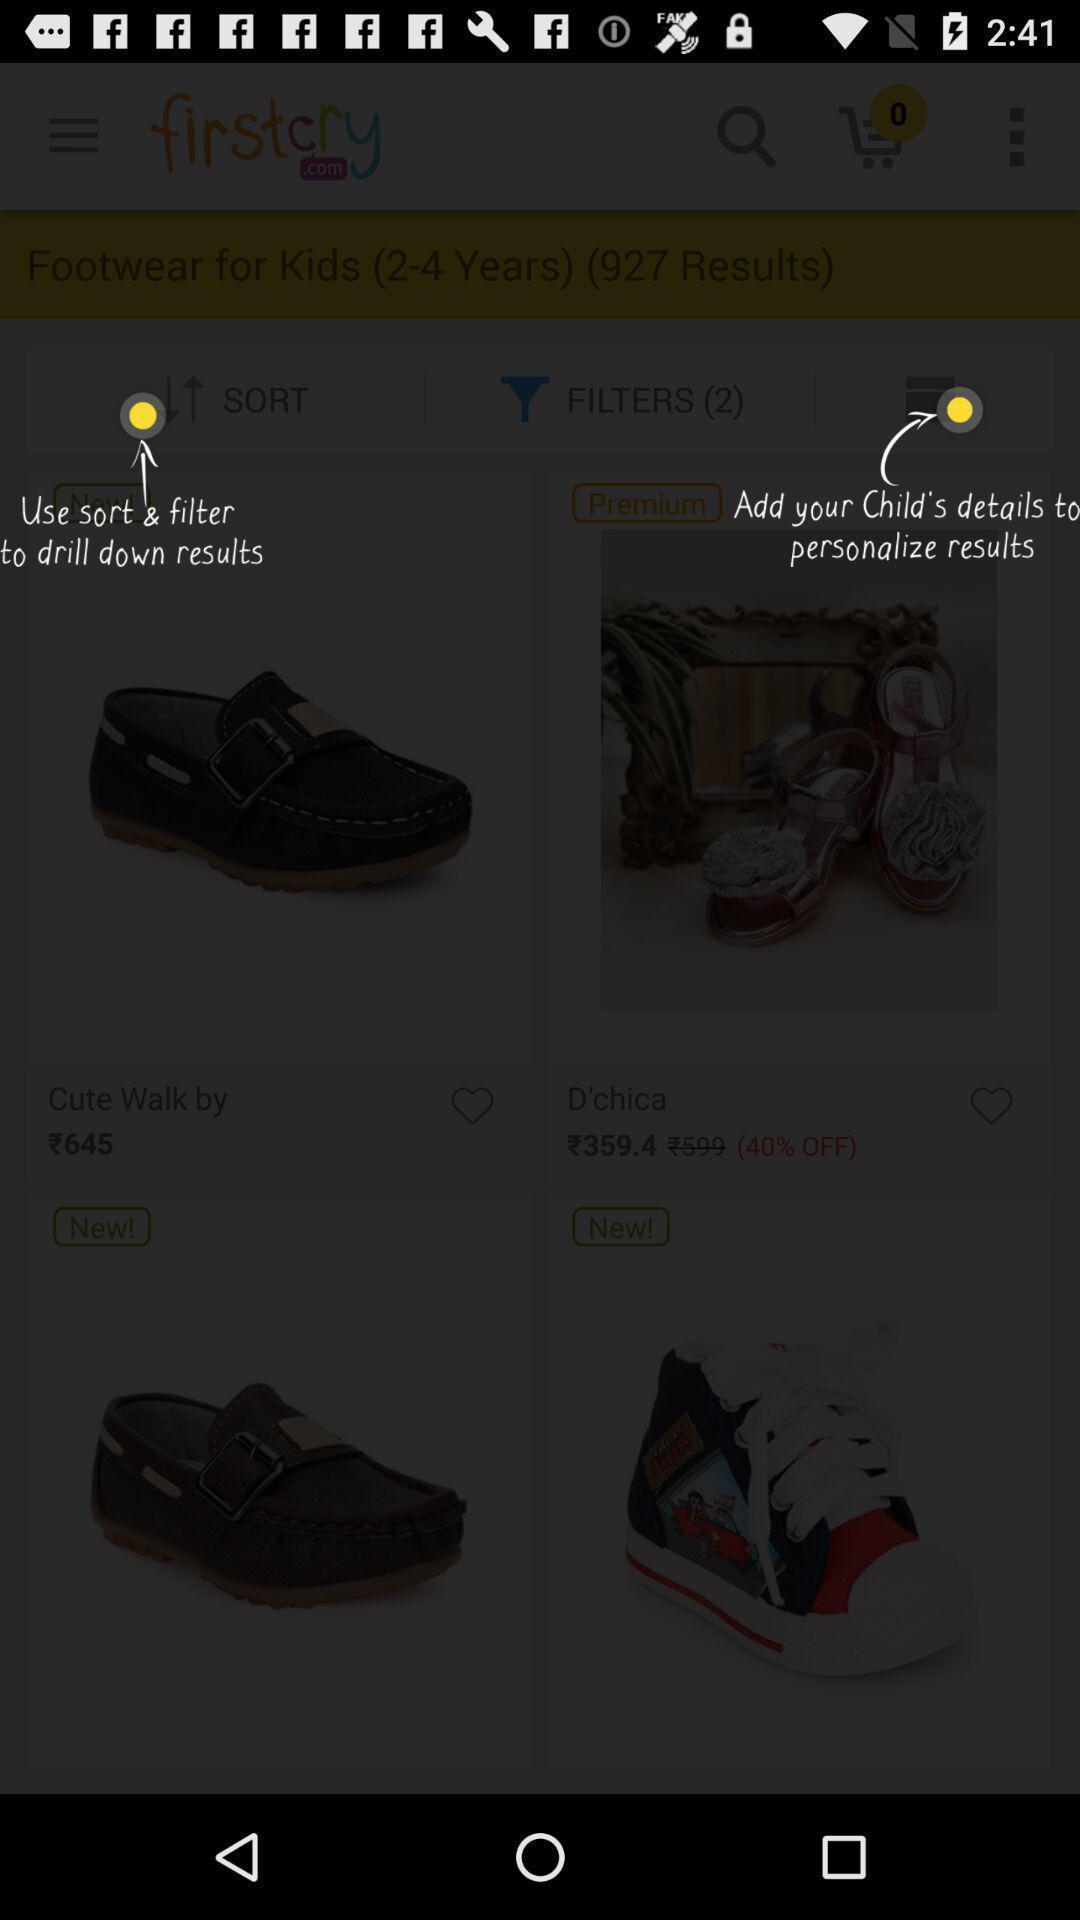Summarize the information in this screenshot. Screen showing hints to add filter. 